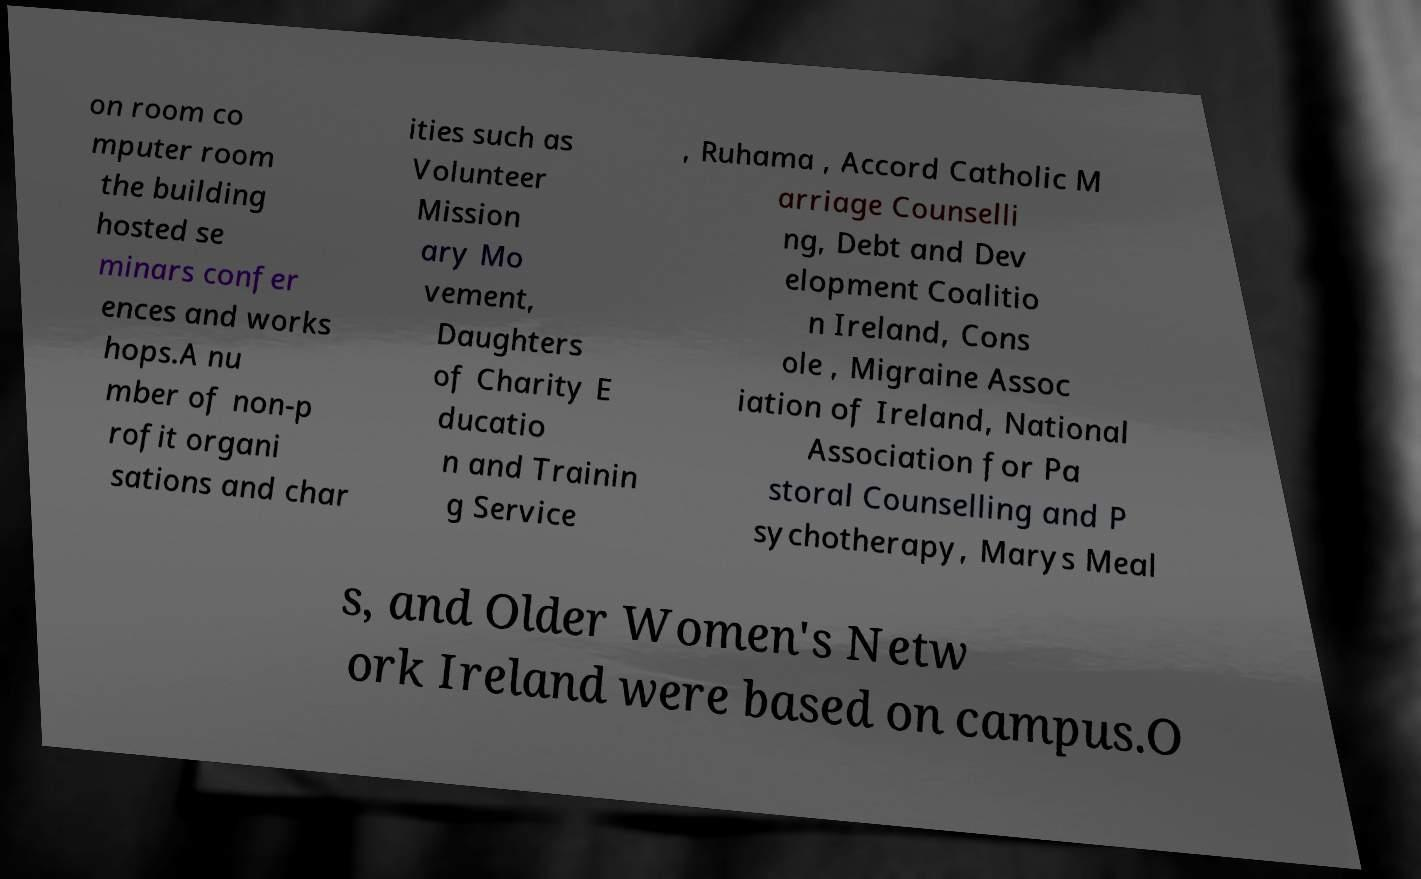I need the written content from this picture converted into text. Can you do that? on room co mputer room the building hosted se minars confer ences and works hops.A nu mber of non-p rofit organi sations and char ities such as Volunteer Mission ary Mo vement, Daughters of Charity E ducatio n and Trainin g Service , Ruhama , Accord Catholic M arriage Counselli ng, Debt and Dev elopment Coalitio n Ireland, Cons ole , Migraine Assoc iation of Ireland, National Association for Pa storal Counselling and P sychotherapy, Marys Meal s, and Older Women's Netw ork Ireland were based on campus.O 